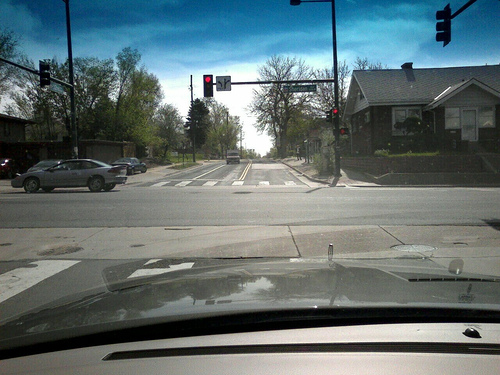What time of day does it look like in the image? Given the long shadows on the road, it seems to be either early morning or late afternoon, typical times for such shadows to be cast in that direction. 